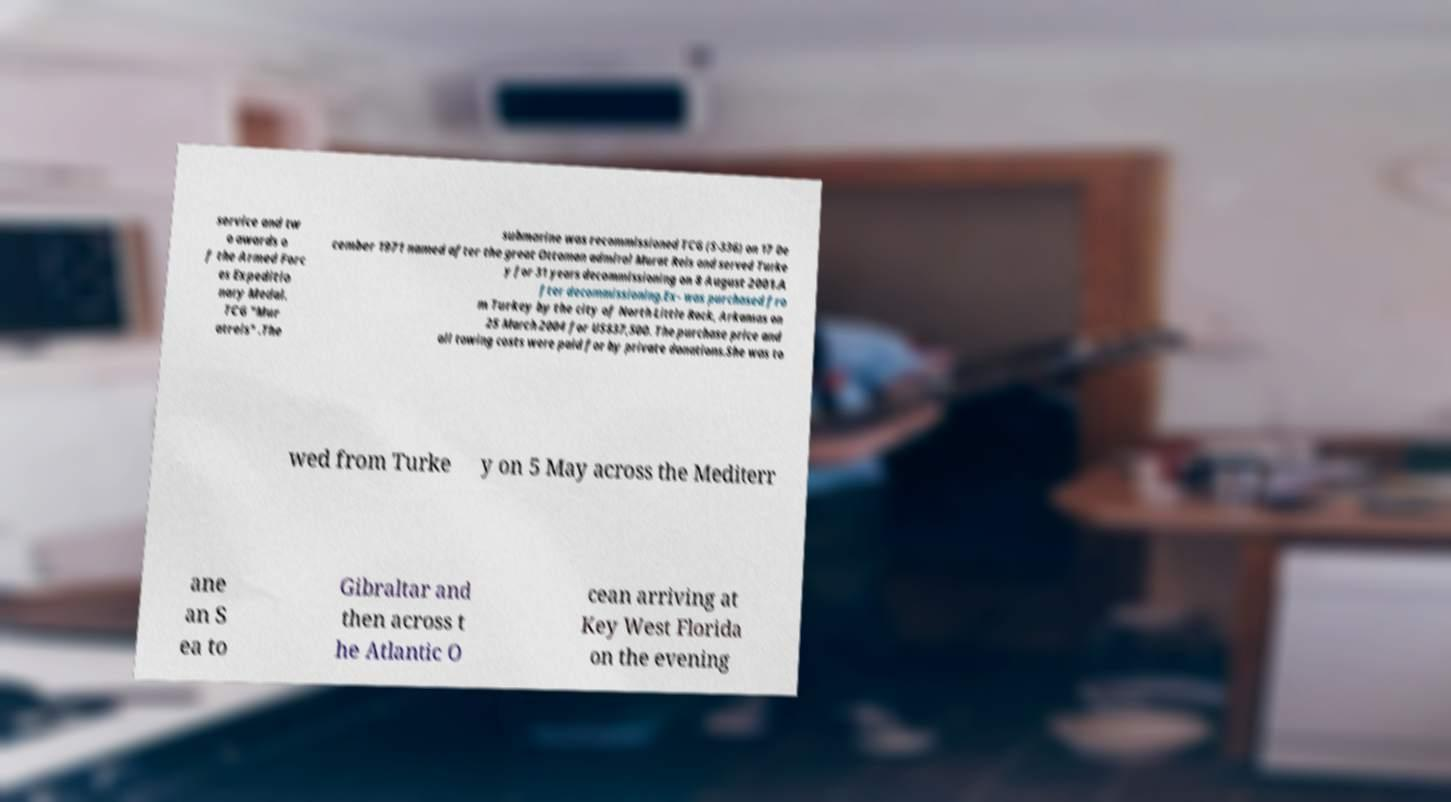Please read and relay the text visible in this image. What does it say? service and tw o awards o f the Armed Forc es Expeditio nary Medal. TCG "Mur atreis" .The submarine was recommissioned TCG (S-336) on 17 De cember 1971 named after the great Ottoman admiral Murat Reis and served Turke y for 31 years decommissioning on 8 August 2001.A fter decommissioning.Ex- was purchased fro m Turkey by the city of North Little Rock, Arkansas on 25 March 2004 for US$37,500. The purchase price and all towing costs were paid for by private donations.She was to wed from Turke y on 5 May across the Mediterr ane an S ea to Gibraltar and then across t he Atlantic O cean arriving at Key West Florida on the evening 